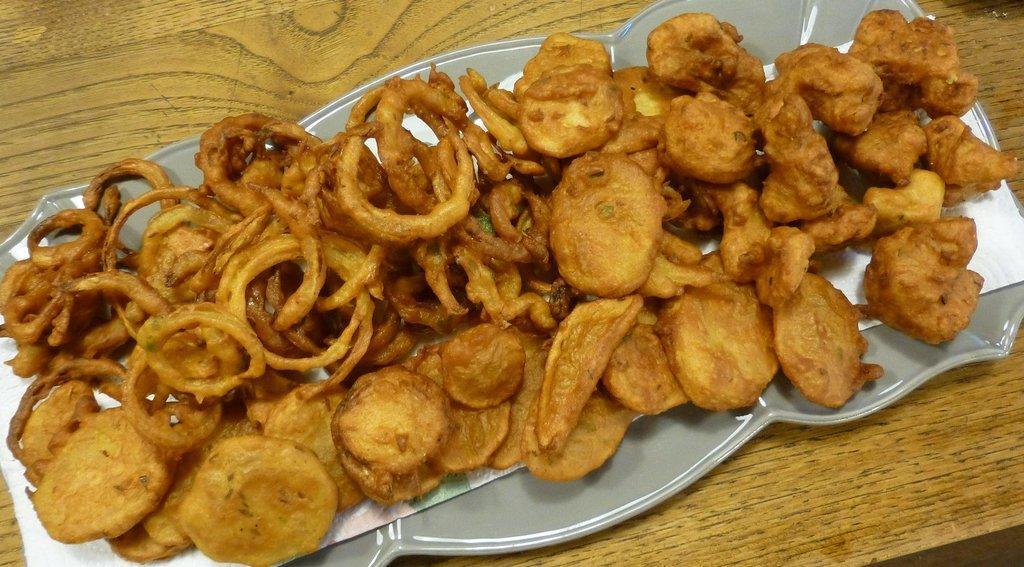Could you give a brief overview of what you see in this image? In this picture we can see a table. On the table we can see a plate which contains food and paper. 